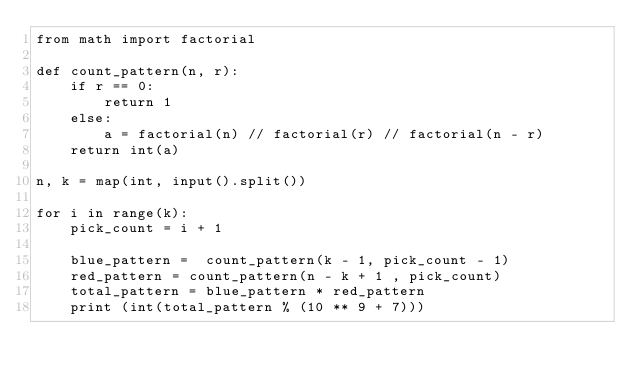<code> <loc_0><loc_0><loc_500><loc_500><_Python_>from math import factorial

def count_pattern(n, r):
    if r == 0:
        return 1
    else:
        a = factorial(n) // factorial(r) // factorial(n - r)
    return int(a)

n, k = map(int, input().split())

for i in range(k):
    pick_count = i + 1

    blue_pattern =  count_pattern(k - 1, pick_count - 1)
    red_pattern = count_pattern(n - k + 1 , pick_count)
    total_pattern = blue_pattern * red_pattern
    print (int(total_pattern % (10 ** 9 + 7)))
</code> 